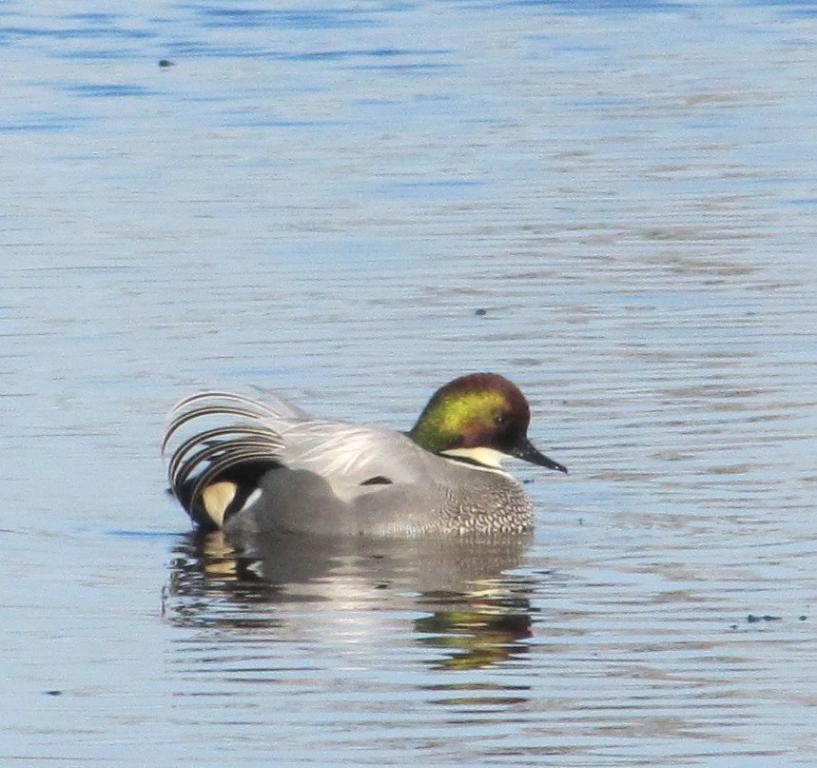What type of animal can be seen in the image? There is a bird in the image. What colors are present on the bird? The bird has black, silver, grey, green, and brown colors. Where is the bird located in the image? The bird is on the surface of the water. How does the bird crush the wrist in the image? There is no wrist present in the image, and the bird is not shown interacting with any object or person. 